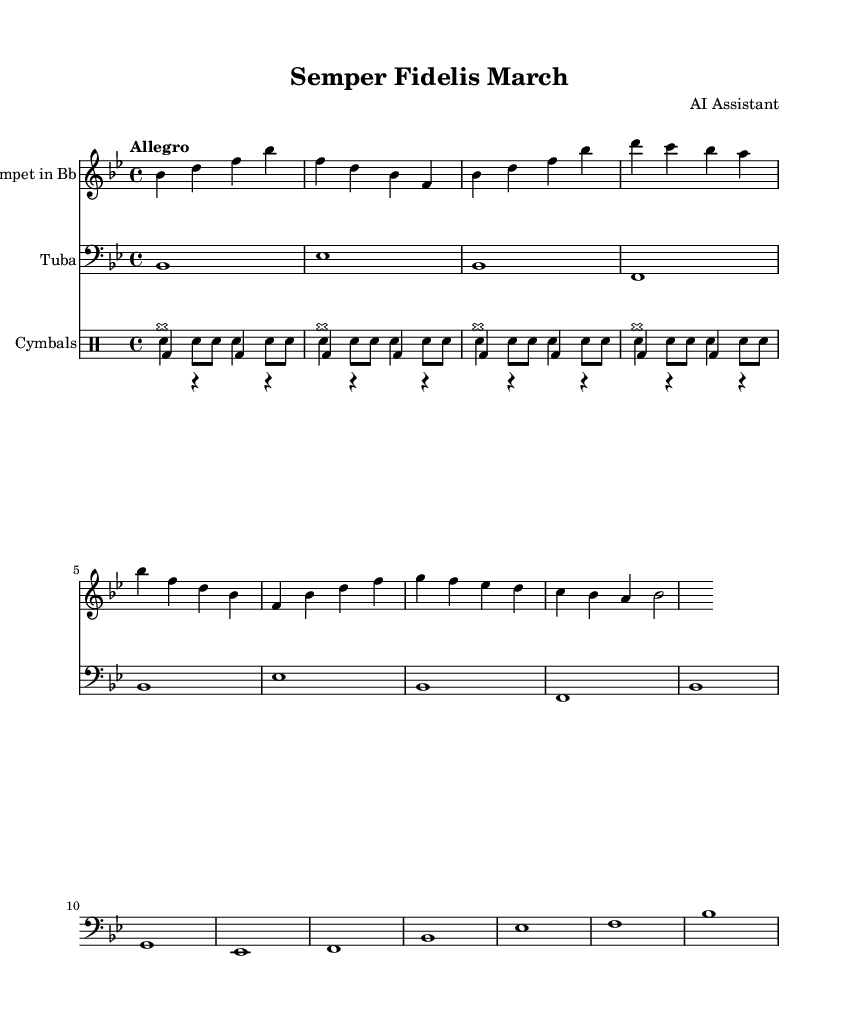What is the key signature of this music? The key signature is B flat major, which contains two flats (B flat and E flat) in the scale. This can be determined by looking at the key signature at the beginning of the sheet music, which indicates the specified flats.
Answer: B flat major What is the time signature of this symphony? The time signature is 4/4, which means there are four beats per measure and the quarter note gets one beat. This can be identified by examining the time signature symbol at the start of the music.
Answer: 4/4 What is the tempo marking for this piece? The tempo marking is "Allegro," which indicates a fast and lively pace. This is clearly stated in the tempo indication found above the staff at the beginning of the piece.
Answer: Allegro How many different instruments are there in this score? There are three distinct instrumental parts indicated in the score: one for the trumpet, one for the tuba, and a drum staff that includes snare drum, bass drum, and cymbals. This can be observed in the layout of the score where each instrument is labeled separately.
Answer: Three What is the instrument playing the melody in this symphony? The melody is primarily played by the trumpet in B flat, as seen by the prominence of the trumpet part at the top of the score, which features the main melodic lines written in it.
Answer: Trumpet in B flat Which percussion instrument plays the basic rhythmic foundation in this piece? The bass drum plays the basic rhythmic foundation, providing the steady beat in most measures accompanying the snare drum. This is noted in the drum section of the score, where the bass drum part primarily focuses on maintaining the pulse.
Answer: Bass drum 